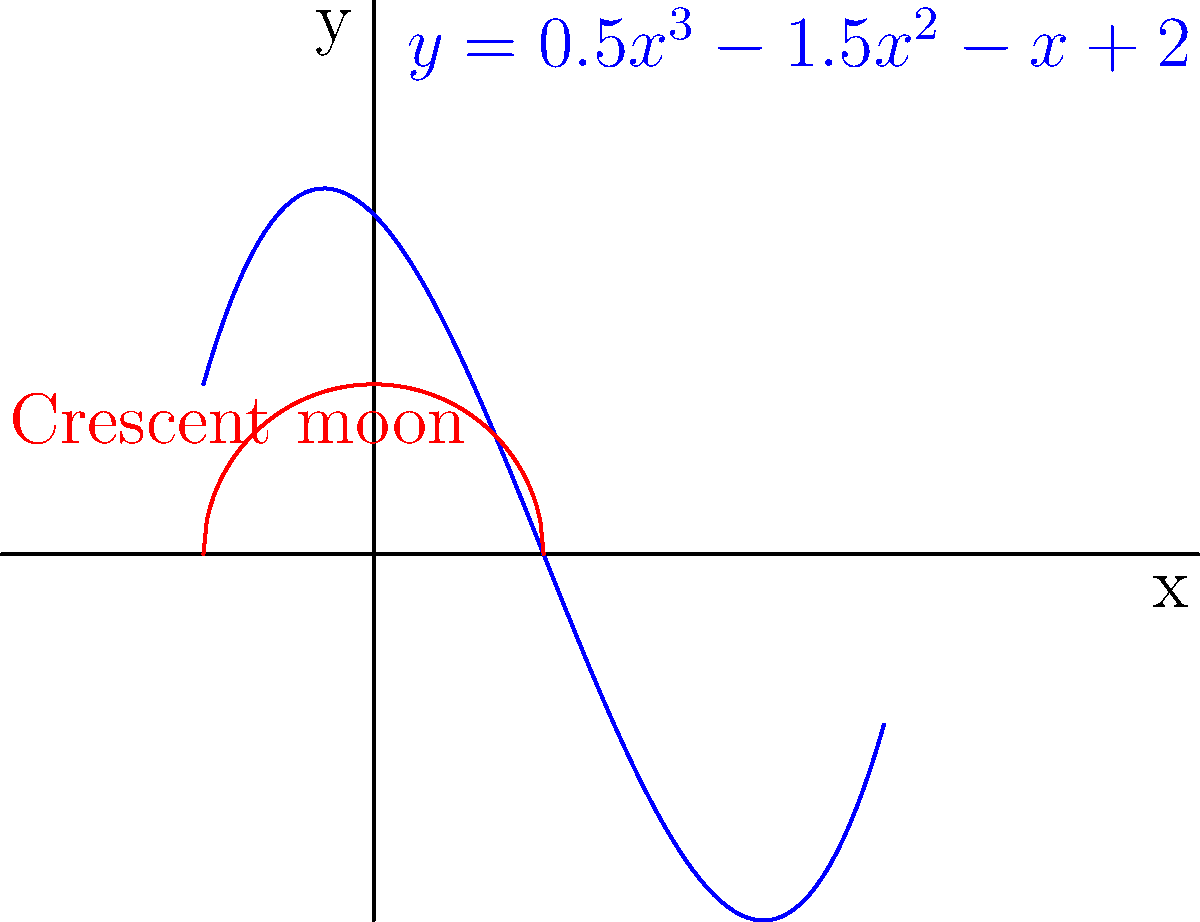As you gaze at the night sky with your owner, you notice a crescent moon that reminds you of a polynomial curve. The blue curve represents the polynomial $f(x)=0.5x^3-1.5x^2-x+2$, while the red curve represents the crescent moon. At how many points does the polynomial intersect with the x-axis? To find the number of x-axis intersections, we need to solve the equation:

$0.5x^3-1.5x^2-x+2 = 0$

Let's approach this step-by-step:

1) This is a cubic equation, so it can have up to 3 real roots.

2) We can use the rational root theorem to find potential rational roots. The potential rational roots are the factors of the constant term (2): ±1, ±2.

3) By testing these values, we find that x = 2 is a root of the equation.

4) We can factor out (x - 2):

   $0.5x^3-1.5x^2-x+2 = (x-2)(0.5x^2+0.5x-1)$

5) Now we need to solve the quadratic equation $0.5x^2+0.5x-1 = 0$

6) Using the quadratic formula, we get:

   $x = \frac{-0.5 \pm \sqrt{0.25 + 2}}{1} = \frac{-0.5 \pm \sqrt{2.25}}{1} = \frac{-0.5 \pm 1.5}{1}$

7) This gives us two more roots: x = 1 and x = -2

Therefore, the polynomial intersects the x-axis at three points: x = -2, x = 1, and x = 2.
Answer: 3 